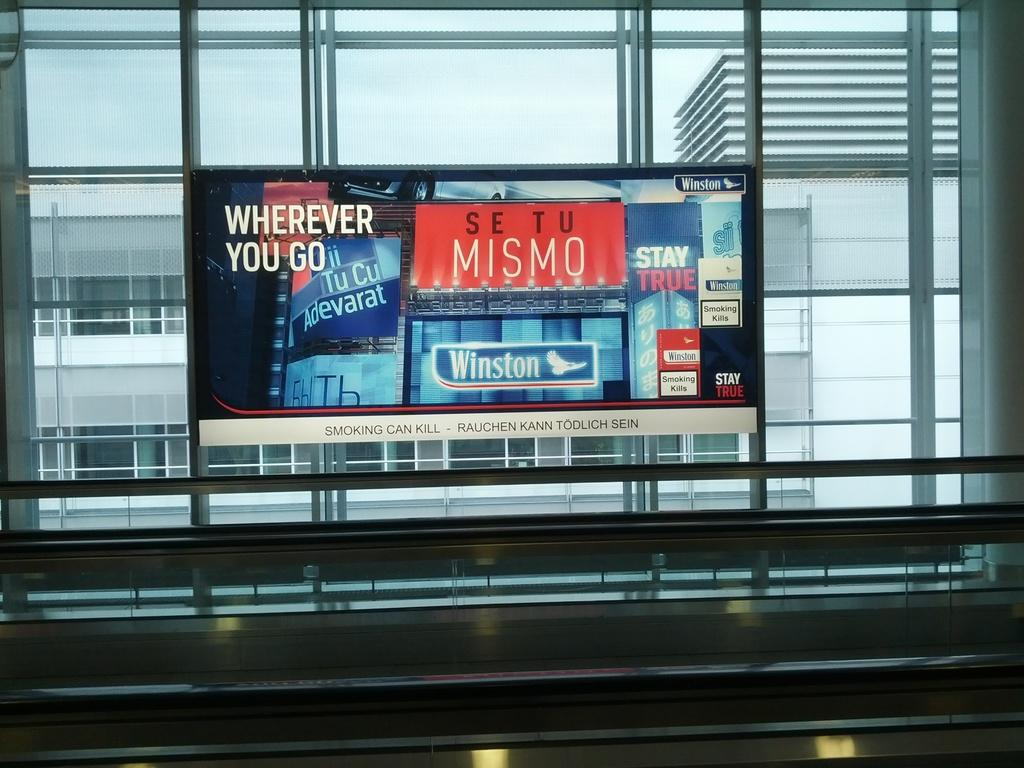<image>
Offer a succinct explanation of the picture presented. A monitor with a display reading Wherever you go se tu Mismo. 